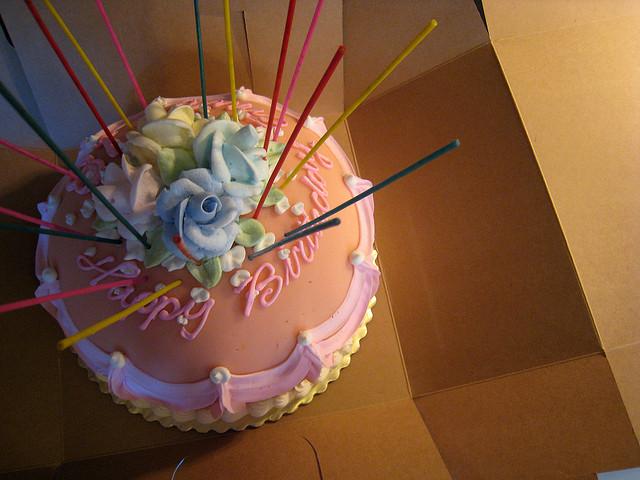Are there items here that look like knitting needles, yet aren't?
Write a very short answer. Yes. What is in box?
Short answer required. Cake. What is the occasion?
Give a very brief answer. Birthday. 